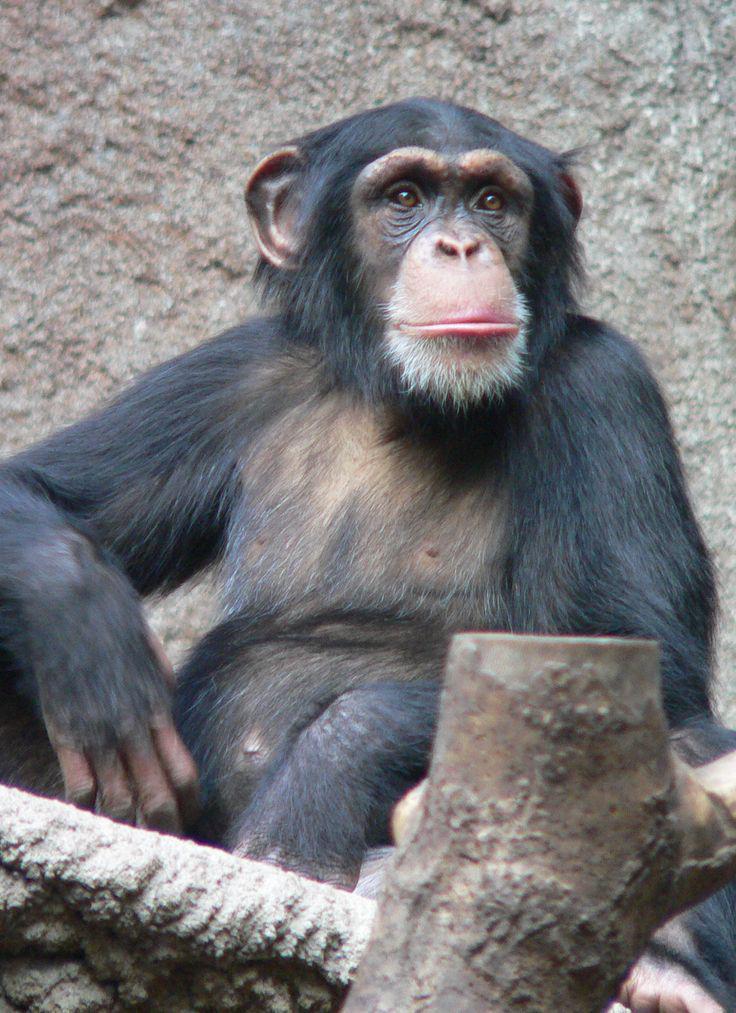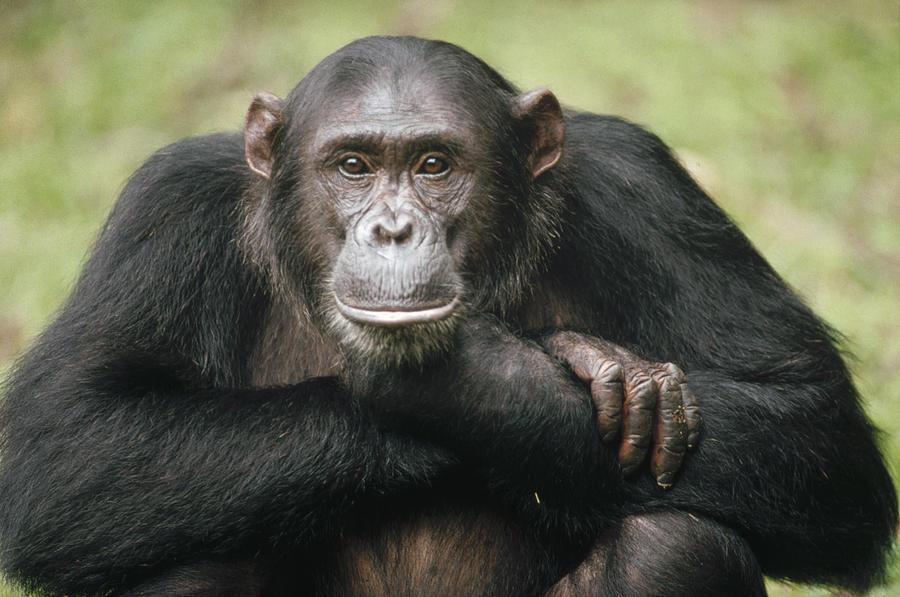The first image is the image on the left, the second image is the image on the right. Examine the images to the left and right. Is the description "in the right image a chimp is making an O with it's mouth" accurate? Answer yes or no. No. The first image is the image on the left, the second image is the image on the right. Evaluate the accuracy of this statement regarding the images: "In one image there is a lone monkey with an open mouth like it is howling.". Is it true? Answer yes or no. No. 